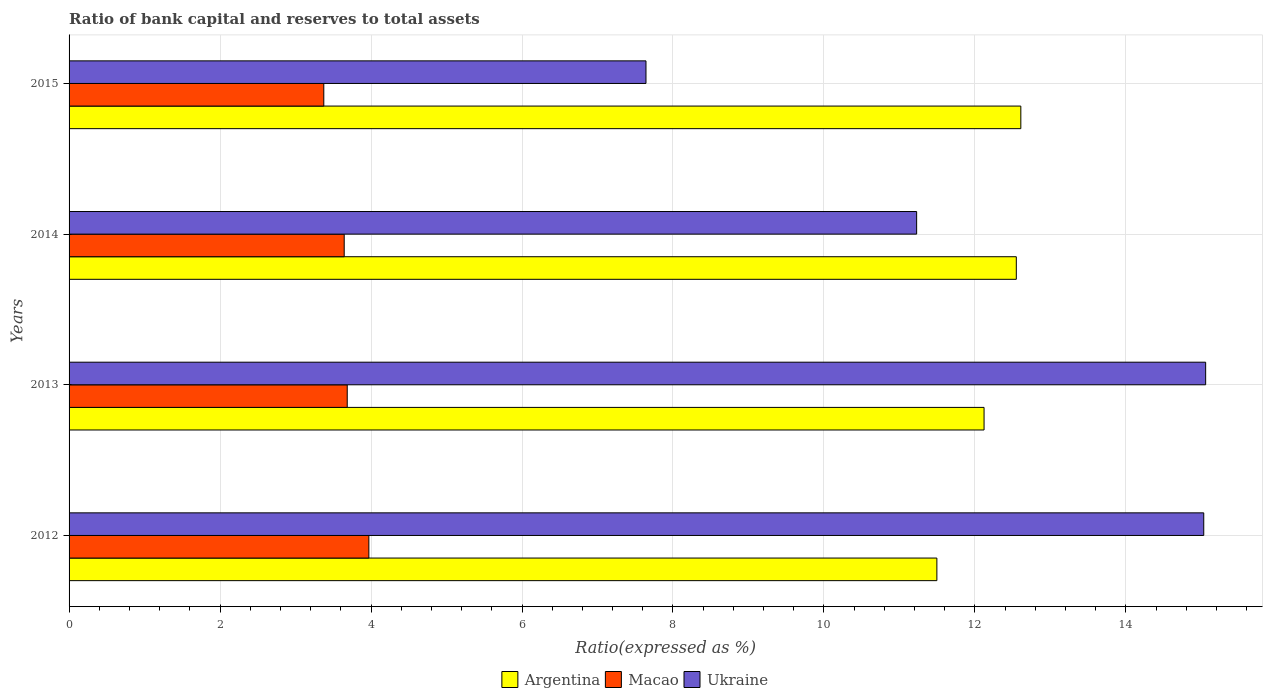Are the number of bars per tick equal to the number of legend labels?
Offer a terse response. Yes. How many bars are there on the 3rd tick from the bottom?
Offer a very short reply. 3. What is the label of the 3rd group of bars from the top?
Provide a short and direct response. 2013. What is the ratio of bank capital and reserves to total assets in Macao in 2014?
Provide a short and direct response. 3.64. Across all years, what is the maximum ratio of bank capital and reserves to total assets in Ukraine?
Make the answer very short. 15.06. Across all years, what is the minimum ratio of bank capital and reserves to total assets in Macao?
Provide a succinct answer. 3.37. In which year was the ratio of bank capital and reserves to total assets in Argentina maximum?
Your answer should be compact. 2015. In which year was the ratio of bank capital and reserves to total assets in Ukraine minimum?
Ensure brevity in your answer.  2015. What is the total ratio of bank capital and reserves to total assets in Macao in the graph?
Ensure brevity in your answer.  14.68. What is the difference between the ratio of bank capital and reserves to total assets in Ukraine in 2013 and that in 2014?
Give a very brief answer. 3.83. What is the difference between the ratio of bank capital and reserves to total assets in Argentina in 2014 and the ratio of bank capital and reserves to total assets in Ukraine in 2015?
Make the answer very short. 4.91. What is the average ratio of bank capital and reserves to total assets in Macao per year?
Offer a terse response. 3.67. In the year 2012, what is the difference between the ratio of bank capital and reserves to total assets in Argentina and ratio of bank capital and reserves to total assets in Ukraine?
Your answer should be very brief. -3.54. In how many years, is the ratio of bank capital and reserves to total assets in Ukraine greater than 7.2 %?
Your response must be concise. 4. What is the ratio of the ratio of bank capital and reserves to total assets in Macao in 2012 to that in 2015?
Give a very brief answer. 1.18. Is the ratio of bank capital and reserves to total assets in Macao in 2014 less than that in 2015?
Your answer should be compact. No. Is the difference between the ratio of bank capital and reserves to total assets in Argentina in 2014 and 2015 greater than the difference between the ratio of bank capital and reserves to total assets in Ukraine in 2014 and 2015?
Keep it short and to the point. No. What is the difference between the highest and the second highest ratio of bank capital and reserves to total assets in Macao?
Give a very brief answer. 0.29. What is the difference between the highest and the lowest ratio of bank capital and reserves to total assets in Argentina?
Ensure brevity in your answer.  1.11. In how many years, is the ratio of bank capital and reserves to total assets in Argentina greater than the average ratio of bank capital and reserves to total assets in Argentina taken over all years?
Offer a terse response. 2. What does the 3rd bar from the top in 2013 represents?
Make the answer very short. Argentina. What does the 1st bar from the bottom in 2012 represents?
Your response must be concise. Argentina. Is it the case that in every year, the sum of the ratio of bank capital and reserves to total assets in Argentina and ratio of bank capital and reserves to total assets in Macao is greater than the ratio of bank capital and reserves to total assets in Ukraine?
Provide a short and direct response. Yes. How many bars are there?
Give a very brief answer. 12. Are all the bars in the graph horizontal?
Ensure brevity in your answer.  Yes. What is the difference between two consecutive major ticks on the X-axis?
Your answer should be compact. 2. Are the values on the major ticks of X-axis written in scientific E-notation?
Your answer should be very brief. No. Does the graph contain grids?
Your response must be concise. Yes. Where does the legend appear in the graph?
Your answer should be compact. Bottom center. How many legend labels are there?
Your answer should be compact. 3. How are the legend labels stacked?
Your answer should be compact. Horizontal. What is the title of the graph?
Offer a very short reply. Ratio of bank capital and reserves to total assets. Does "Venezuela" appear as one of the legend labels in the graph?
Your answer should be very brief. No. What is the label or title of the X-axis?
Your answer should be very brief. Ratio(expressed as %). What is the label or title of the Y-axis?
Your response must be concise. Years. What is the Ratio(expressed as %) in Argentina in 2012?
Offer a terse response. 11.5. What is the Ratio(expressed as %) of Macao in 2012?
Offer a terse response. 3.97. What is the Ratio(expressed as %) of Ukraine in 2012?
Provide a short and direct response. 15.03. What is the Ratio(expressed as %) in Argentina in 2013?
Your answer should be very brief. 12.12. What is the Ratio(expressed as %) in Macao in 2013?
Offer a very short reply. 3.68. What is the Ratio(expressed as %) in Ukraine in 2013?
Keep it short and to the point. 15.06. What is the Ratio(expressed as %) of Argentina in 2014?
Your answer should be very brief. 12.55. What is the Ratio(expressed as %) of Macao in 2014?
Your answer should be very brief. 3.64. What is the Ratio(expressed as %) in Ukraine in 2014?
Offer a very short reply. 11.23. What is the Ratio(expressed as %) in Argentina in 2015?
Provide a succinct answer. 12.61. What is the Ratio(expressed as %) in Macao in 2015?
Your response must be concise. 3.37. What is the Ratio(expressed as %) of Ukraine in 2015?
Offer a terse response. 7.64. Across all years, what is the maximum Ratio(expressed as %) of Argentina?
Your answer should be compact. 12.61. Across all years, what is the maximum Ratio(expressed as %) in Macao?
Offer a very short reply. 3.97. Across all years, what is the maximum Ratio(expressed as %) of Ukraine?
Provide a succinct answer. 15.06. Across all years, what is the minimum Ratio(expressed as %) in Argentina?
Your answer should be very brief. 11.5. Across all years, what is the minimum Ratio(expressed as %) in Macao?
Give a very brief answer. 3.37. Across all years, what is the minimum Ratio(expressed as %) in Ukraine?
Your answer should be very brief. 7.64. What is the total Ratio(expressed as %) of Argentina in the graph?
Your answer should be very brief. 48.77. What is the total Ratio(expressed as %) in Macao in the graph?
Give a very brief answer. 14.68. What is the total Ratio(expressed as %) in Ukraine in the graph?
Offer a terse response. 48.96. What is the difference between the Ratio(expressed as %) in Argentina in 2012 and that in 2013?
Make the answer very short. -0.62. What is the difference between the Ratio(expressed as %) in Macao in 2012 and that in 2013?
Make the answer very short. 0.29. What is the difference between the Ratio(expressed as %) in Ukraine in 2012 and that in 2013?
Provide a short and direct response. -0.03. What is the difference between the Ratio(expressed as %) of Argentina in 2012 and that in 2014?
Provide a short and direct response. -1.05. What is the difference between the Ratio(expressed as %) of Macao in 2012 and that in 2014?
Your response must be concise. 0.33. What is the difference between the Ratio(expressed as %) in Ukraine in 2012 and that in 2014?
Your answer should be very brief. 3.8. What is the difference between the Ratio(expressed as %) of Argentina in 2012 and that in 2015?
Make the answer very short. -1.11. What is the difference between the Ratio(expressed as %) of Macao in 2012 and that in 2015?
Give a very brief answer. 0.6. What is the difference between the Ratio(expressed as %) in Ukraine in 2012 and that in 2015?
Your answer should be compact. 7.39. What is the difference between the Ratio(expressed as %) in Argentina in 2013 and that in 2014?
Provide a short and direct response. -0.43. What is the difference between the Ratio(expressed as %) of Macao in 2013 and that in 2014?
Keep it short and to the point. 0.04. What is the difference between the Ratio(expressed as %) in Ukraine in 2013 and that in 2014?
Make the answer very short. 3.83. What is the difference between the Ratio(expressed as %) of Argentina in 2013 and that in 2015?
Your answer should be very brief. -0.49. What is the difference between the Ratio(expressed as %) in Macao in 2013 and that in 2015?
Make the answer very short. 0.31. What is the difference between the Ratio(expressed as %) in Ukraine in 2013 and that in 2015?
Offer a terse response. 7.41. What is the difference between the Ratio(expressed as %) of Argentina in 2014 and that in 2015?
Your answer should be very brief. -0.06. What is the difference between the Ratio(expressed as %) in Macao in 2014 and that in 2015?
Make the answer very short. 0.27. What is the difference between the Ratio(expressed as %) of Ukraine in 2014 and that in 2015?
Ensure brevity in your answer.  3.59. What is the difference between the Ratio(expressed as %) in Argentina in 2012 and the Ratio(expressed as %) in Macao in 2013?
Provide a succinct answer. 7.81. What is the difference between the Ratio(expressed as %) of Argentina in 2012 and the Ratio(expressed as %) of Ukraine in 2013?
Keep it short and to the point. -3.56. What is the difference between the Ratio(expressed as %) in Macao in 2012 and the Ratio(expressed as %) in Ukraine in 2013?
Provide a succinct answer. -11.09. What is the difference between the Ratio(expressed as %) of Argentina in 2012 and the Ratio(expressed as %) of Macao in 2014?
Give a very brief answer. 7.85. What is the difference between the Ratio(expressed as %) in Argentina in 2012 and the Ratio(expressed as %) in Ukraine in 2014?
Your answer should be compact. 0.27. What is the difference between the Ratio(expressed as %) in Macao in 2012 and the Ratio(expressed as %) in Ukraine in 2014?
Ensure brevity in your answer.  -7.26. What is the difference between the Ratio(expressed as %) of Argentina in 2012 and the Ratio(expressed as %) of Macao in 2015?
Your answer should be very brief. 8.12. What is the difference between the Ratio(expressed as %) of Argentina in 2012 and the Ratio(expressed as %) of Ukraine in 2015?
Keep it short and to the point. 3.85. What is the difference between the Ratio(expressed as %) in Macao in 2012 and the Ratio(expressed as %) in Ukraine in 2015?
Provide a short and direct response. -3.67. What is the difference between the Ratio(expressed as %) in Argentina in 2013 and the Ratio(expressed as %) in Macao in 2014?
Make the answer very short. 8.48. What is the difference between the Ratio(expressed as %) of Argentina in 2013 and the Ratio(expressed as %) of Ukraine in 2014?
Offer a terse response. 0.89. What is the difference between the Ratio(expressed as %) of Macao in 2013 and the Ratio(expressed as %) of Ukraine in 2014?
Make the answer very short. -7.54. What is the difference between the Ratio(expressed as %) of Argentina in 2013 and the Ratio(expressed as %) of Macao in 2015?
Offer a very short reply. 8.75. What is the difference between the Ratio(expressed as %) of Argentina in 2013 and the Ratio(expressed as %) of Ukraine in 2015?
Give a very brief answer. 4.48. What is the difference between the Ratio(expressed as %) of Macao in 2013 and the Ratio(expressed as %) of Ukraine in 2015?
Your answer should be compact. -3.96. What is the difference between the Ratio(expressed as %) of Argentina in 2014 and the Ratio(expressed as %) of Macao in 2015?
Provide a succinct answer. 9.17. What is the difference between the Ratio(expressed as %) in Argentina in 2014 and the Ratio(expressed as %) in Ukraine in 2015?
Your answer should be very brief. 4.91. What is the difference between the Ratio(expressed as %) in Macao in 2014 and the Ratio(expressed as %) in Ukraine in 2015?
Make the answer very short. -4. What is the average Ratio(expressed as %) in Argentina per year?
Your response must be concise. 12.19. What is the average Ratio(expressed as %) in Macao per year?
Ensure brevity in your answer.  3.67. What is the average Ratio(expressed as %) in Ukraine per year?
Offer a terse response. 12.24. In the year 2012, what is the difference between the Ratio(expressed as %) of Argentina and Ratio(expressed as %) of Macao?
Your response must be concise. 7.52. In the year 2012, what is the difference between the Ratio(expressed as %) in Argentina and Ratio(expressed as %) in Ukraine?
Your answer should be compact. -3.54. In the year 2012, what is the difference between the Ratio(expressed as %) of Macao and Ratio(expressed as %) of Ukraine?
Provide a short and direct response. -11.06. In the year 2013, what is the difference between the Ratio(expressed as %) of Argentina and Ratio(expressed as %) of Macao?
Give a very brief answer. 8.44. In the year 2013, what is the difference between the Ratio(expressed as %) of Argentina and Ratio(expressed as %) of Ukraine?
Provide a succinct answer. -2.94. In the year 2013, what is the difference between the Ratio(expressed as %) in Macao and Ratio(expressed as %) in Ukraine?
Your response must be concise. -11.37. In the year 2014, what is the difference between the Ratio(expressed as %) of Argentina and Ratio(expressed as %) of Macao?
Provide a short and direct response. 8.9. In the year 2014, what is the difference between the Ratio(expressed as %) in Argentina and Ratio(expressed as %) in Ukraine?
Your answer should be very brief. 1.32. In the year 2014, what is the difference between the Ratio(expressed as %) in Macao and Ratio(expressed as %) in Ukraine?
Keep it short and to the point. -7.58. In the year 2015, what is the difference between the Ratio(expressed as %) of Argentina and Ratio(expressed as %) of Macao?
Offer a terse response. 9.23. In the year 2015, what is the difference between the Ratio(expressed as %) in Argentina and Ratio(expressed as %) in Ukraine?
Offer a terse response. 4.97. In the year 2015, what is the difference between the Ratio(expressed as %) of Macao and Ratio(expressed as %) of Ukraine?
Give a very brief answer. -4.27. What is the ratio of the Ratio(expressed as %) of Argentina in 2012 to that in 2013?
Provide a short and direct response. 0.95. What is the ratio of the Ratio(expressed as %) in Macao in 2012 to that in 2013?
Make the answer very short. 1.08. What is the ratio of the Ratio(expressed as %) in Ukraine in 2012 to that in 2013?
Give a very brief answer. 1. What is the ratio of the Ratio(expressed as %) of Argentina in 2012 to that in 2014?
Offer a very short reply. 0.92. What is the ratio of the Ratio(expressed as %) of Macao in 2012 to that in 2014?
Offer a very short reply. 1.09. What is the ratio of the Ratio(expressed as %) of Ukraine in 2012 to that in 2014?
Your answer should be very brief. 1.34. What is the ratio of the Ratio(expressed as %) of Argentina in 2012 to that in 2015?
Ensure brevity in your answer.  0.91. What is the ratio of the Ratio(expressed as %) of Macao in 2012 to that in 2015?
Your response must be concise. 1.18. What is the ratio of the Ratio(expressed as %) of Ukraine in 2012 to that in 2015?
Your answer should be compact. 1.97. What is the ratio of the Ratio(expressed as %) in Argentina in 2013 to that in 2014?
Offer a terse response. 0.97. What is the ratio of the Ratio(expressed as %) in Ukraine in 2013 to that in 2014?
Provide a short and direct response. 1.34. What is the ratio of the Ratio(expressed as %) of Argentina in 2013 to that in 2015?
Offer a very short reply. 0.96. What is the ratio of the Ratio(expressed as %) of Macao in 2013 to that in 2015?
Give a very brief answer. 1.09. What is the ratio of the Ratio(expressed as %) in Ukraine in 2013 to that in 2015?
Provide a succinct answer. 1.97. What is the ratio of the Ratio(expressed as %) in Macao in 2014 to that in 2015?
Offer a very short reply. 1.08. What is the ratio of the Ratio(expressed as %) in Ukraine in 2014 to that in 2015?
Your answer should be compact. 1.47. What is the difference between the highest and the second highest Ratio(expressed as %) in Argentina?
Your answer should be very brief. 0.06. What is the difference between the highest and the second highest Ratio(expressed as %) of Macao?
Provide a succinct answer. 0.29. What is the difference between the highest and the second highest Ratio(expressed as %) of Ukraine?
Provide a short and direct response. 0.03. What is the difference between the highest and the lowest Ratio(expressed as %) in Argentina?
Your answer should be compact. 1.11. What is the difference between the highest and the lowest Ratio(expressed as %) of Macao?
Your answer should be compact. 0.6. What is the difference between the highest and the lowest Ratio(expressed as %) of Ukraine?
Provide a short and direct response. 7.41. 